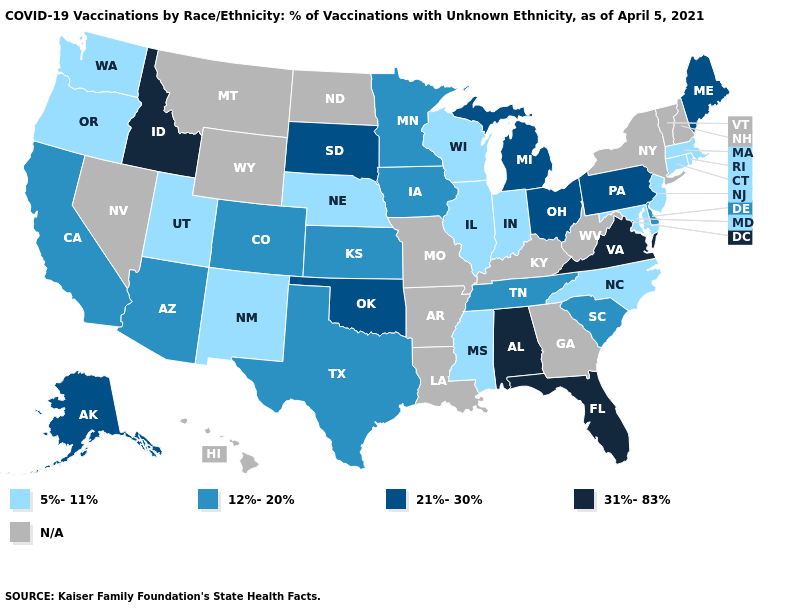Which states have the lowest value in the Northeast?
Quick response, please. Connecticut, Massachusetts, New Jersey, Rhode Island. Name the states that have a value in the range 12%-20%?
Answer briefly. Arizona, California, Colorado, Delaware, Iowa, Kansas, Minnesota, South Carolina, Tennessee, Texas. What is the lowest value in the USA?
Short answer required. 5%-11%. Among the states that border North Dakota , which have the highest value?
Answer briefly. South Dakota. Name the states that have a value in the range 21%-30%?
Give a very brief answer. Alaska, Maine, Michigan, Ohio, Oklahoma, Pennsylvania, South Dakota. Name the states that have a value in the range 12%-20%?
Keep it brief. Arizona, California, Colorado, Delaware, Iowa, Kansas, Minnesota, South Carolina, Tennessee, Texas. What is the value of Wisconsin?
Short answer required. 5%-11%. Name the states that have a value in the range 12%-20%?
Short answer required. Arizona, California, Colorado, Delaware, Iowa, Kansas, Minnesota, South Carolina, Tennessee, Texas. Name the states that have a value in the range 31%-83%?
Answer briefly. Alabama, Florida, Idaho, Virginia. What is the value of Colorado?
Give a very brief answer. 12%-20%. What is the value of Missouri?
Quick response, please. N/A. Does Wisconsin have the highest value in the MidWest?
Quick response, please. No. What is the lowest value in the Northeast?
Keep it brief. 5%-11%. Name the states that have a value in the range 12%-20%?
Quick response, please. Arizona, California, Colorado, Delaware, Iowa, Kansas, Minnesota, South Carolina, Tennessee, Texas. 